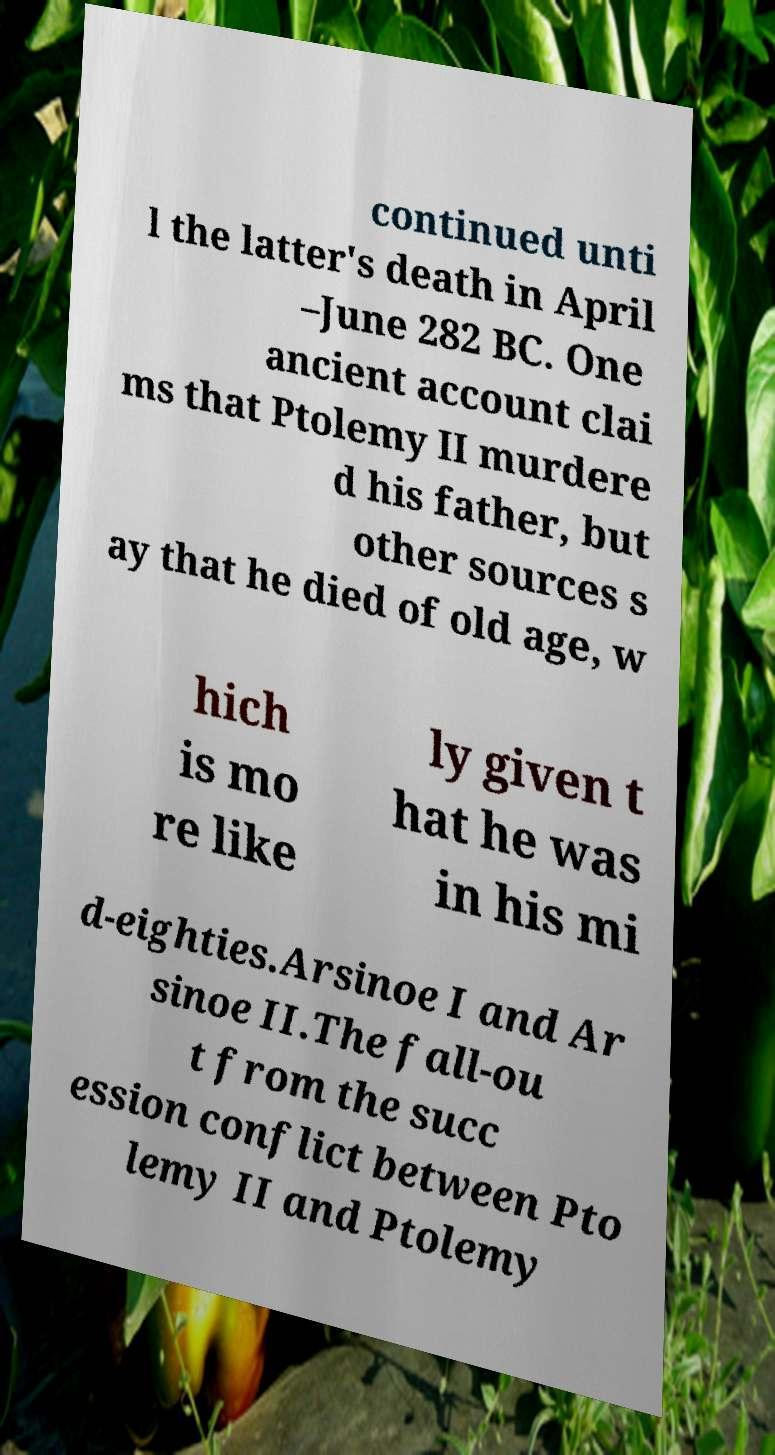Can you accurately transcribe the text from the provided image for me? continued unti l the latter's death in April –June 282 BC. One ancient account clai ms that Ptolemy II murdere d his father, but other sources s ay that he died of old age, w hich is mo re like ly given t hat he was in his mi d-eighties.Arsinoe I and Ar sinoe II.The fall-ou t from the succ ession conflict between Pto lemy II and Ptolemy 